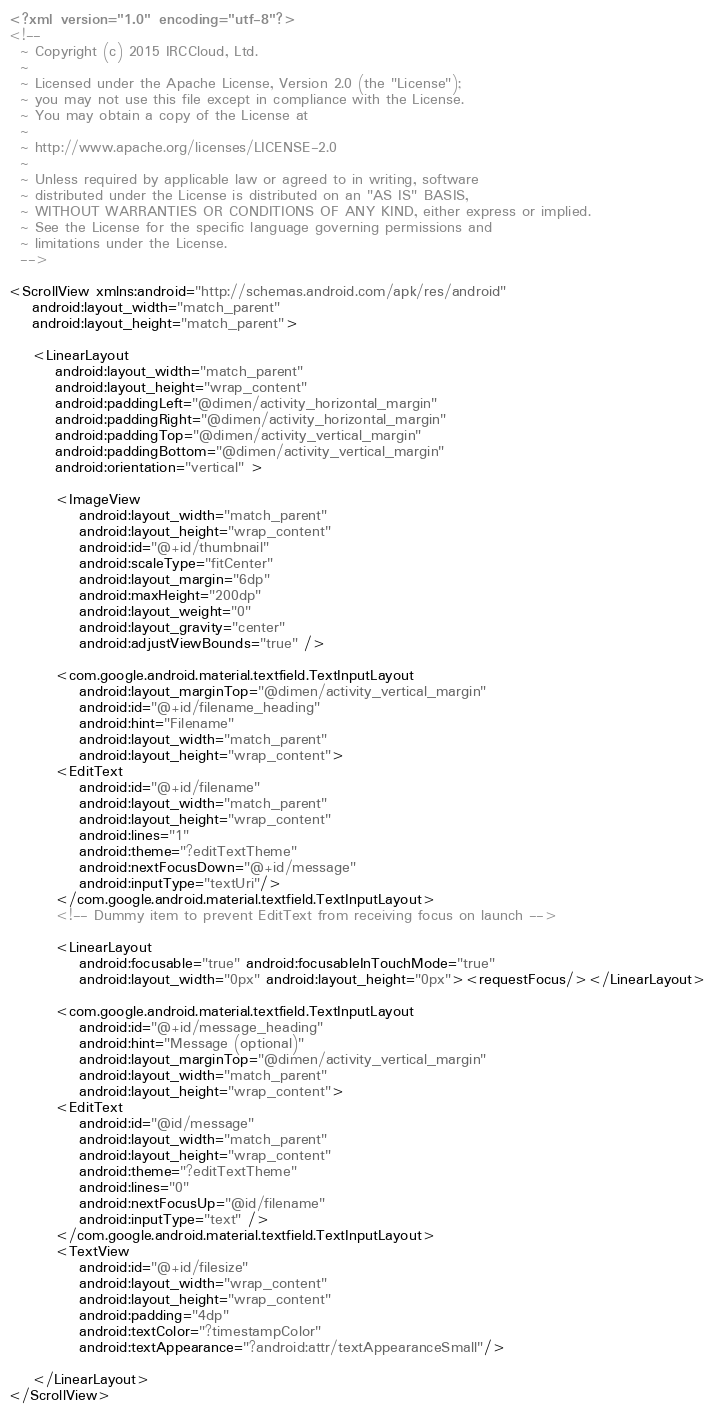Convert code to text. <code><loc_0><loc_0><loc_500><loc_500><_XML_><?xml version="1.0" encoding="utf-8"?>
<!--
  ~ Copyright (c) 2015 IRCCloud, Ltd.
  ~
  ~ Licensed under the Apache License, Version 2.0 (the "License");
  ~ you may not use this file except in compliance with the License.
  ~ You may obtain a copy of the License at
  ~
  ~ http://www.apache.org/licenses/LICENSE-2.0
  ~
  ~ Unless required by applicable law or agreed to in writing, software
  ~ distributed under the License is distributed on an "AS IS" BASIS,
  ~ WITHOUT WARRANTIES OR CONDITIONS OF ANY KIND, either express or implied.
  ~ See the License for the specific language governing permissions and
  ~ limitations under the License.
  -->

<ScrollView xmlns:android="http://schemas.android.com/apk/res/android"
    android:layout_width="match_parent"
    android:layout_height="match_parent">

    <LinearLayout
        android:layout_width="match_parent"
        android:layout_height="wrap_content"
        android:paddingLeft="@dimen/activity_horizontal_margin"
        android:paddingRight="@dimen/activity_horizontal_margin"
        android:paddingTop="@dimen/activity_vertical_margin"
        android:paddingBottom="@dimen/activity_vertical_margin"
        android:orientation="vertical" >

        <ImageView
            android:layout_width="match_parent"
            android:layout_height="wrap_content"
            android:id="@+id/thumbnail"
            android:scaleType="fitCenter"
            android:layout_margin="6dp"
            android:maxHeight="200dp"
            android:layout_weight="0"
            android:layout_gravity="center"
            android:adjustViewBounds="true" />

        <com.google.android.material.textfield.TextInputLayout
            android:layout_marginTop="@dimen/activity_vertical_margin"
            android:id="@+id/filename_heading"
            android:hint="Filename"
            android:layout_width="match_parent"
            android:layout_height="wrap_content">
        <EditText
            android:id="@+id/filename"
            android:layout_width="match_parent"
            android:layout_height="wrap_content"
            android:lines="1"
            android:theme="?editTextTheme"
            android:nextFocusDown="@+id/message"
            android:inputType="textUri"/>
        </com.google.android.material.textfield.TextInputLayout>
        <!-- Dummy item to prevent EditText from receiving focus on launch -->

        <LinearLayout
            android:focusable="true" android:focusableInTouchMode="true"
            android:layout_width="0px" android:layout_height="0px"><requestFocus/></LinearLayout>

        <com.google.android.material.textfield.TextInputLayout
            android:id="@+id/message_heading"
            android:hint="Message (optional)"
            android:layout_marginTop="@dimen/activity_vertical_margin"
            android:layout_width="match_parent"
            android:layout_height="wrap_content">
        <EditText
            android:id="@id/message"
            android:layout_width="match_parent"
            android:layout_height="wrap_content"
            android:theme="?editTextTheme"
            android:lines="0"
            android:nextFocusUp="@id/filename"
            android:inputType="text" />
        </com.google.android.material.textfield.TextInputLayout>
        <TextView
            android:id="@+id/filesize"
            android:layout_width="wrap_content"
            android:layout_height="wrap_content"
            android:padding="4dp"
            android:textColor="?timestampColor"
            android:textAppearance="?android:attr/textAppearanceSmall"/>

    </LinearLayout>
</ScrollView></code> 